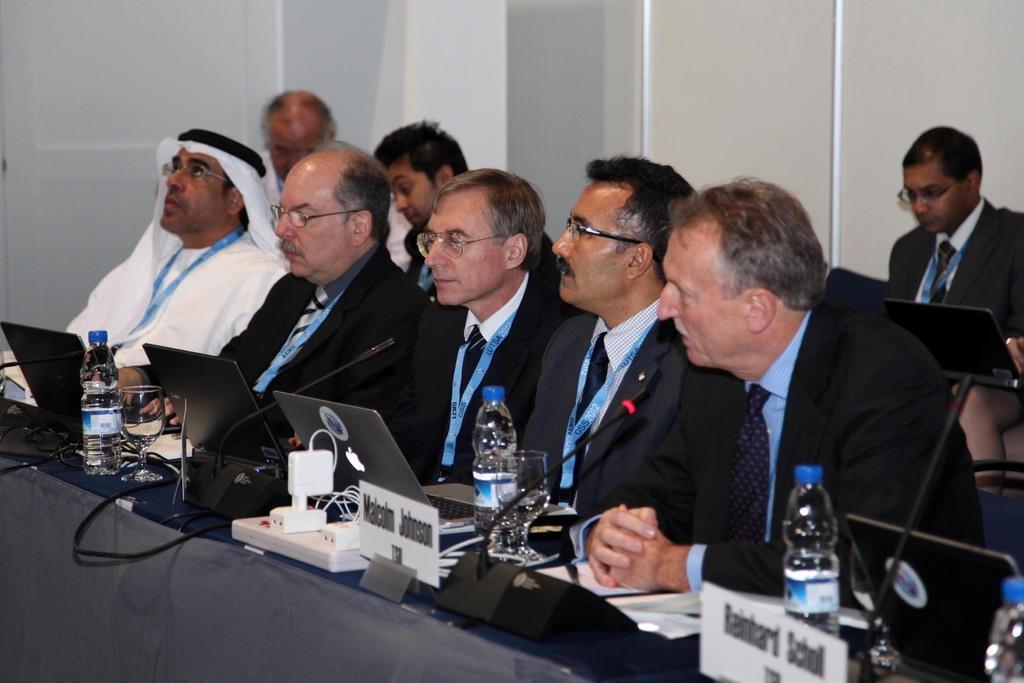In one or two sentences, can you explain what this image depicts? Here we can see few persons are sitting on the chairs. There are laptops, mikes, bottles, name boards, and glasses. In the background we can see wall. 